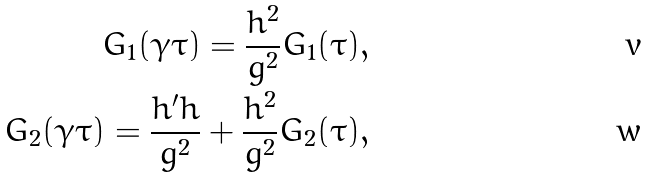<formula> <loc_0><loc_0><loc_500><loc_500>G _ { 1 } ( \gamma \tau ) = \frac { h ^ { 2 } } { g ^ { 2 } } G _ { 1 } ( \tau ) , \\ G _ { 2 } ( \gamma \tau ) = \frac { h ^ { \prime } h } { g ^ { 2 } } + \frac { h ^ { 2 } } { g ^ { 2 } } G _ { 2 } ( \tau ) ,</formula> 